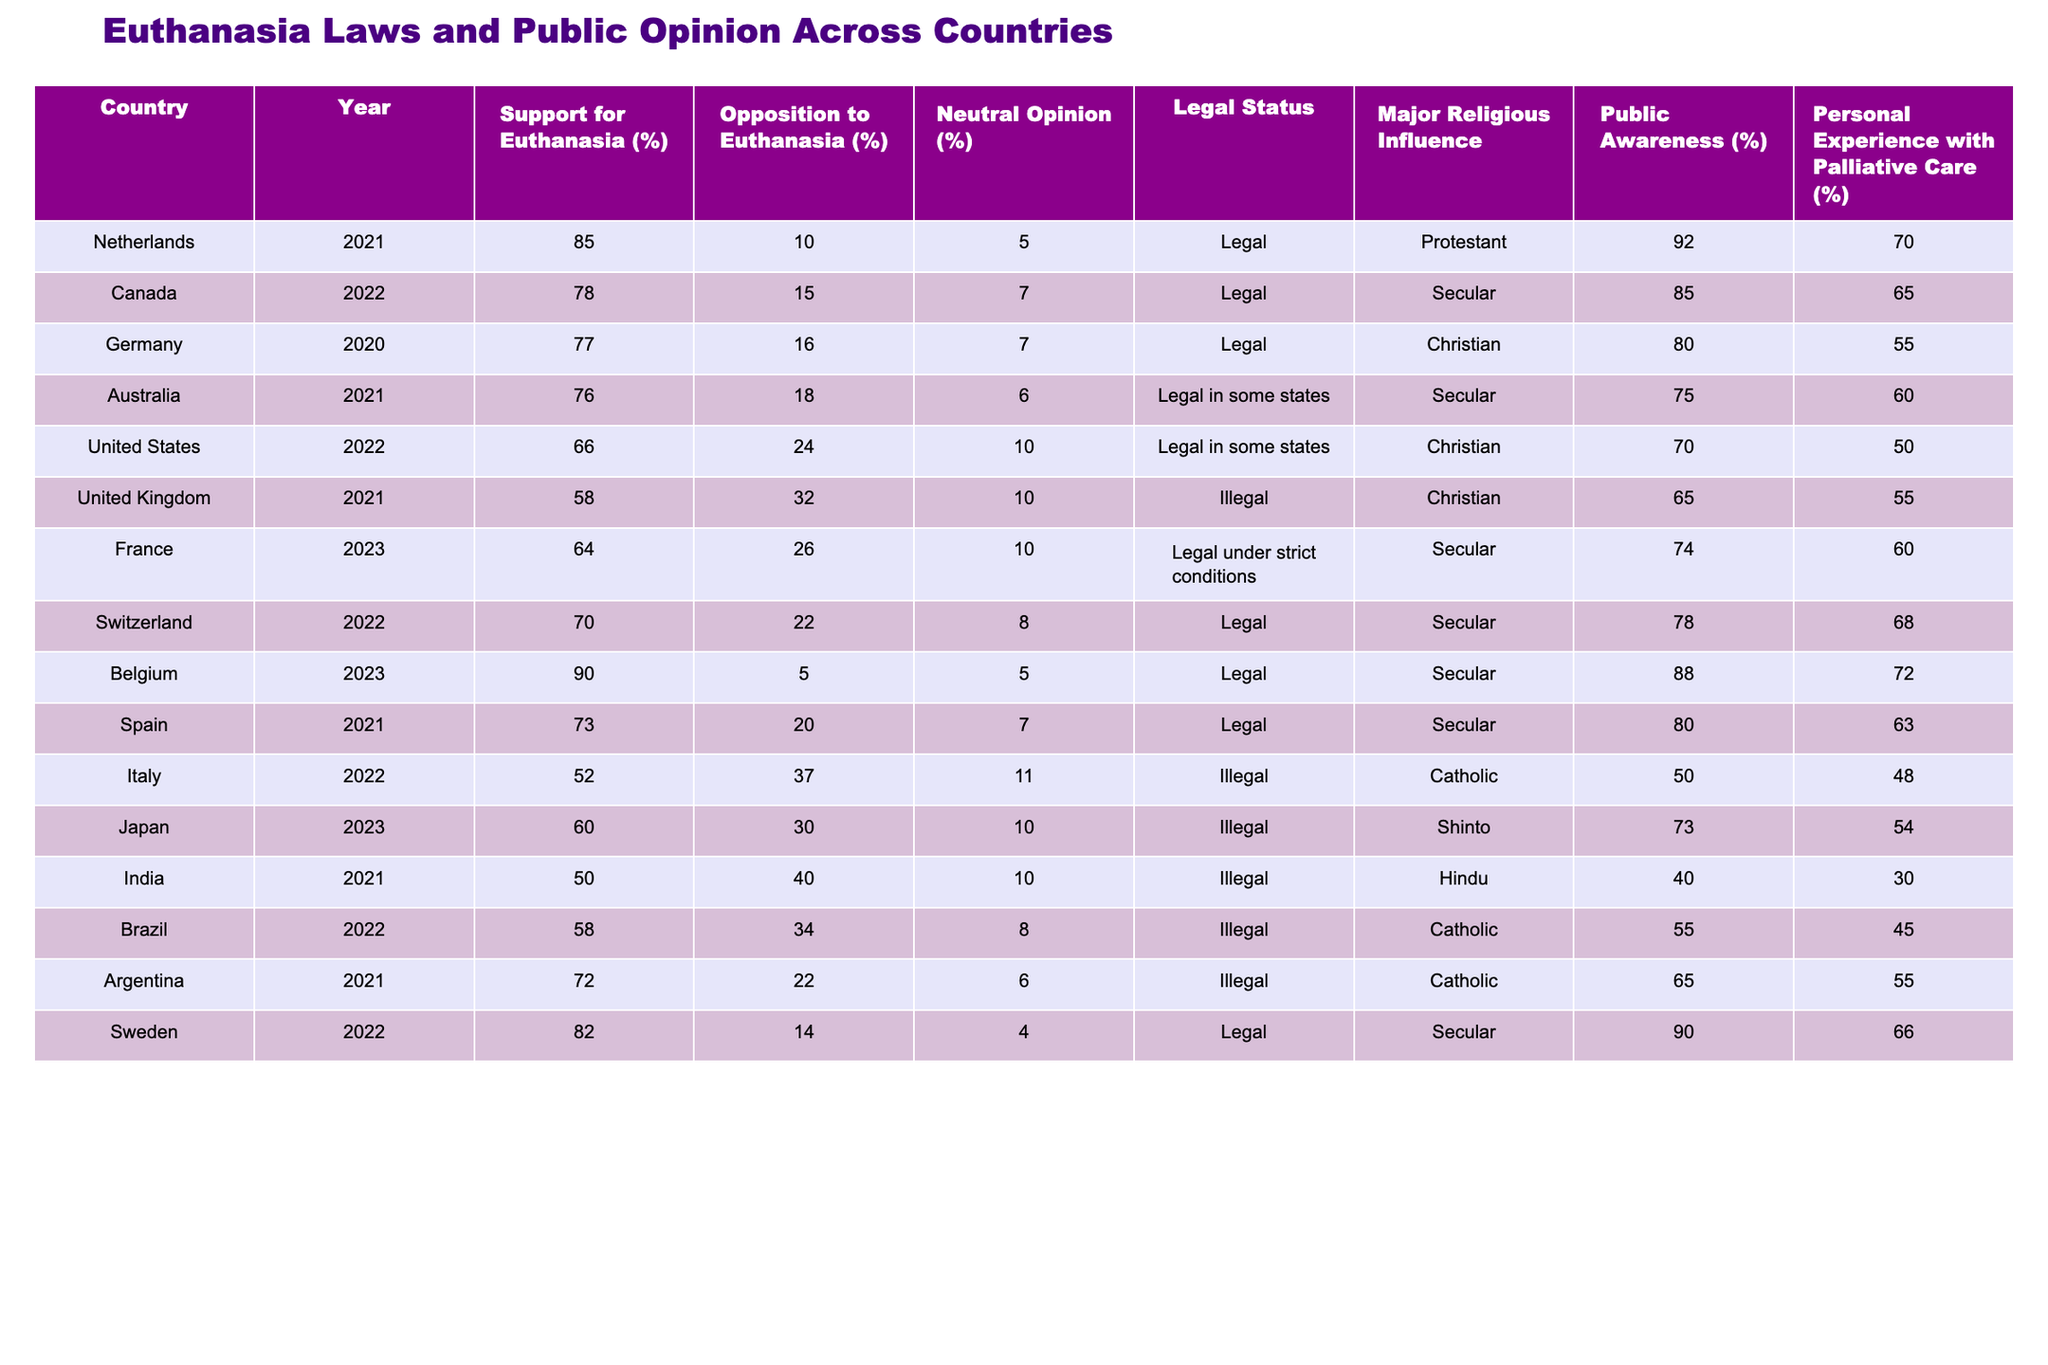What is the percentage of support for euthanasia in Belgium? In the table, look at the row for Belgium, where the "Support for Euthanasia (%)" column shows the value 90.
Answer: 90% Which country has the lowest support for euthanasia? By examining the "Support for Euthanasia (%)" column, India, with a value of 50, has the lowest percentage compared to other countries.
Answer: India Is euthanasia legal in the United Kingdom according to the table? The "Legal Status" column for the United Kingdom indicates that euthanasia is "Illegal."
Answer: Yes What is the average support for euthanasia among countries where it is legal? To find the average, sum the support percentages of all legal countries (85 + 78 + 77 + 76 + 64 + 70 + 90 + 73 + 82) which equals 765. There are 9 legal countries, so 765 / 9 = 85.
Answer: 85% Which two countries have the highest opposition to euthanasia? Looking at the "Opposition to Euthanasia (%)" column, the highest values are Italy with 37% and India with 40%.
Answer: Italy and India What is the relationship between public awareness and support for euthanasia in Sweden? The "Public Awareness (%)" for Sweden is 90, and the "Support for Euthanasia (%)" is 82. This indicates a high level of public awareness correlating with strong support.
Answer: High support and awareness Does Germany have higher public awareness than France? Germany's "Public Awareness (%)" is 80%, while France's is 74%. Since 80 is greater than 74, Germany does indeed have higher public awareness.
Answer: Yes What is the difference in percentage between support for euthanasia in Canada and Italy? The support for euthanasia in Canada is 78% and in Italy it is 52%. The difference is calculated as 78 - 52 = 26%.
Answer: 26% What can be inferred about the role of religion in support for euthanasia in countries like Italy and Germany? Italy, with a strong Catholic influence showing 52% support, contrasts with Germany, where support is 77% despite a Christian influence. This suggests that different contexts of religious influence affect opinions on euthanasia.
Answer: Diverse impact of religion Which country has the highest percentage of personal experience with palliative care? The "Personal Experience with Palliative Care (%)" for Belgium is 72%, the highest in the table compared to other countries.
Answer: Belgium 